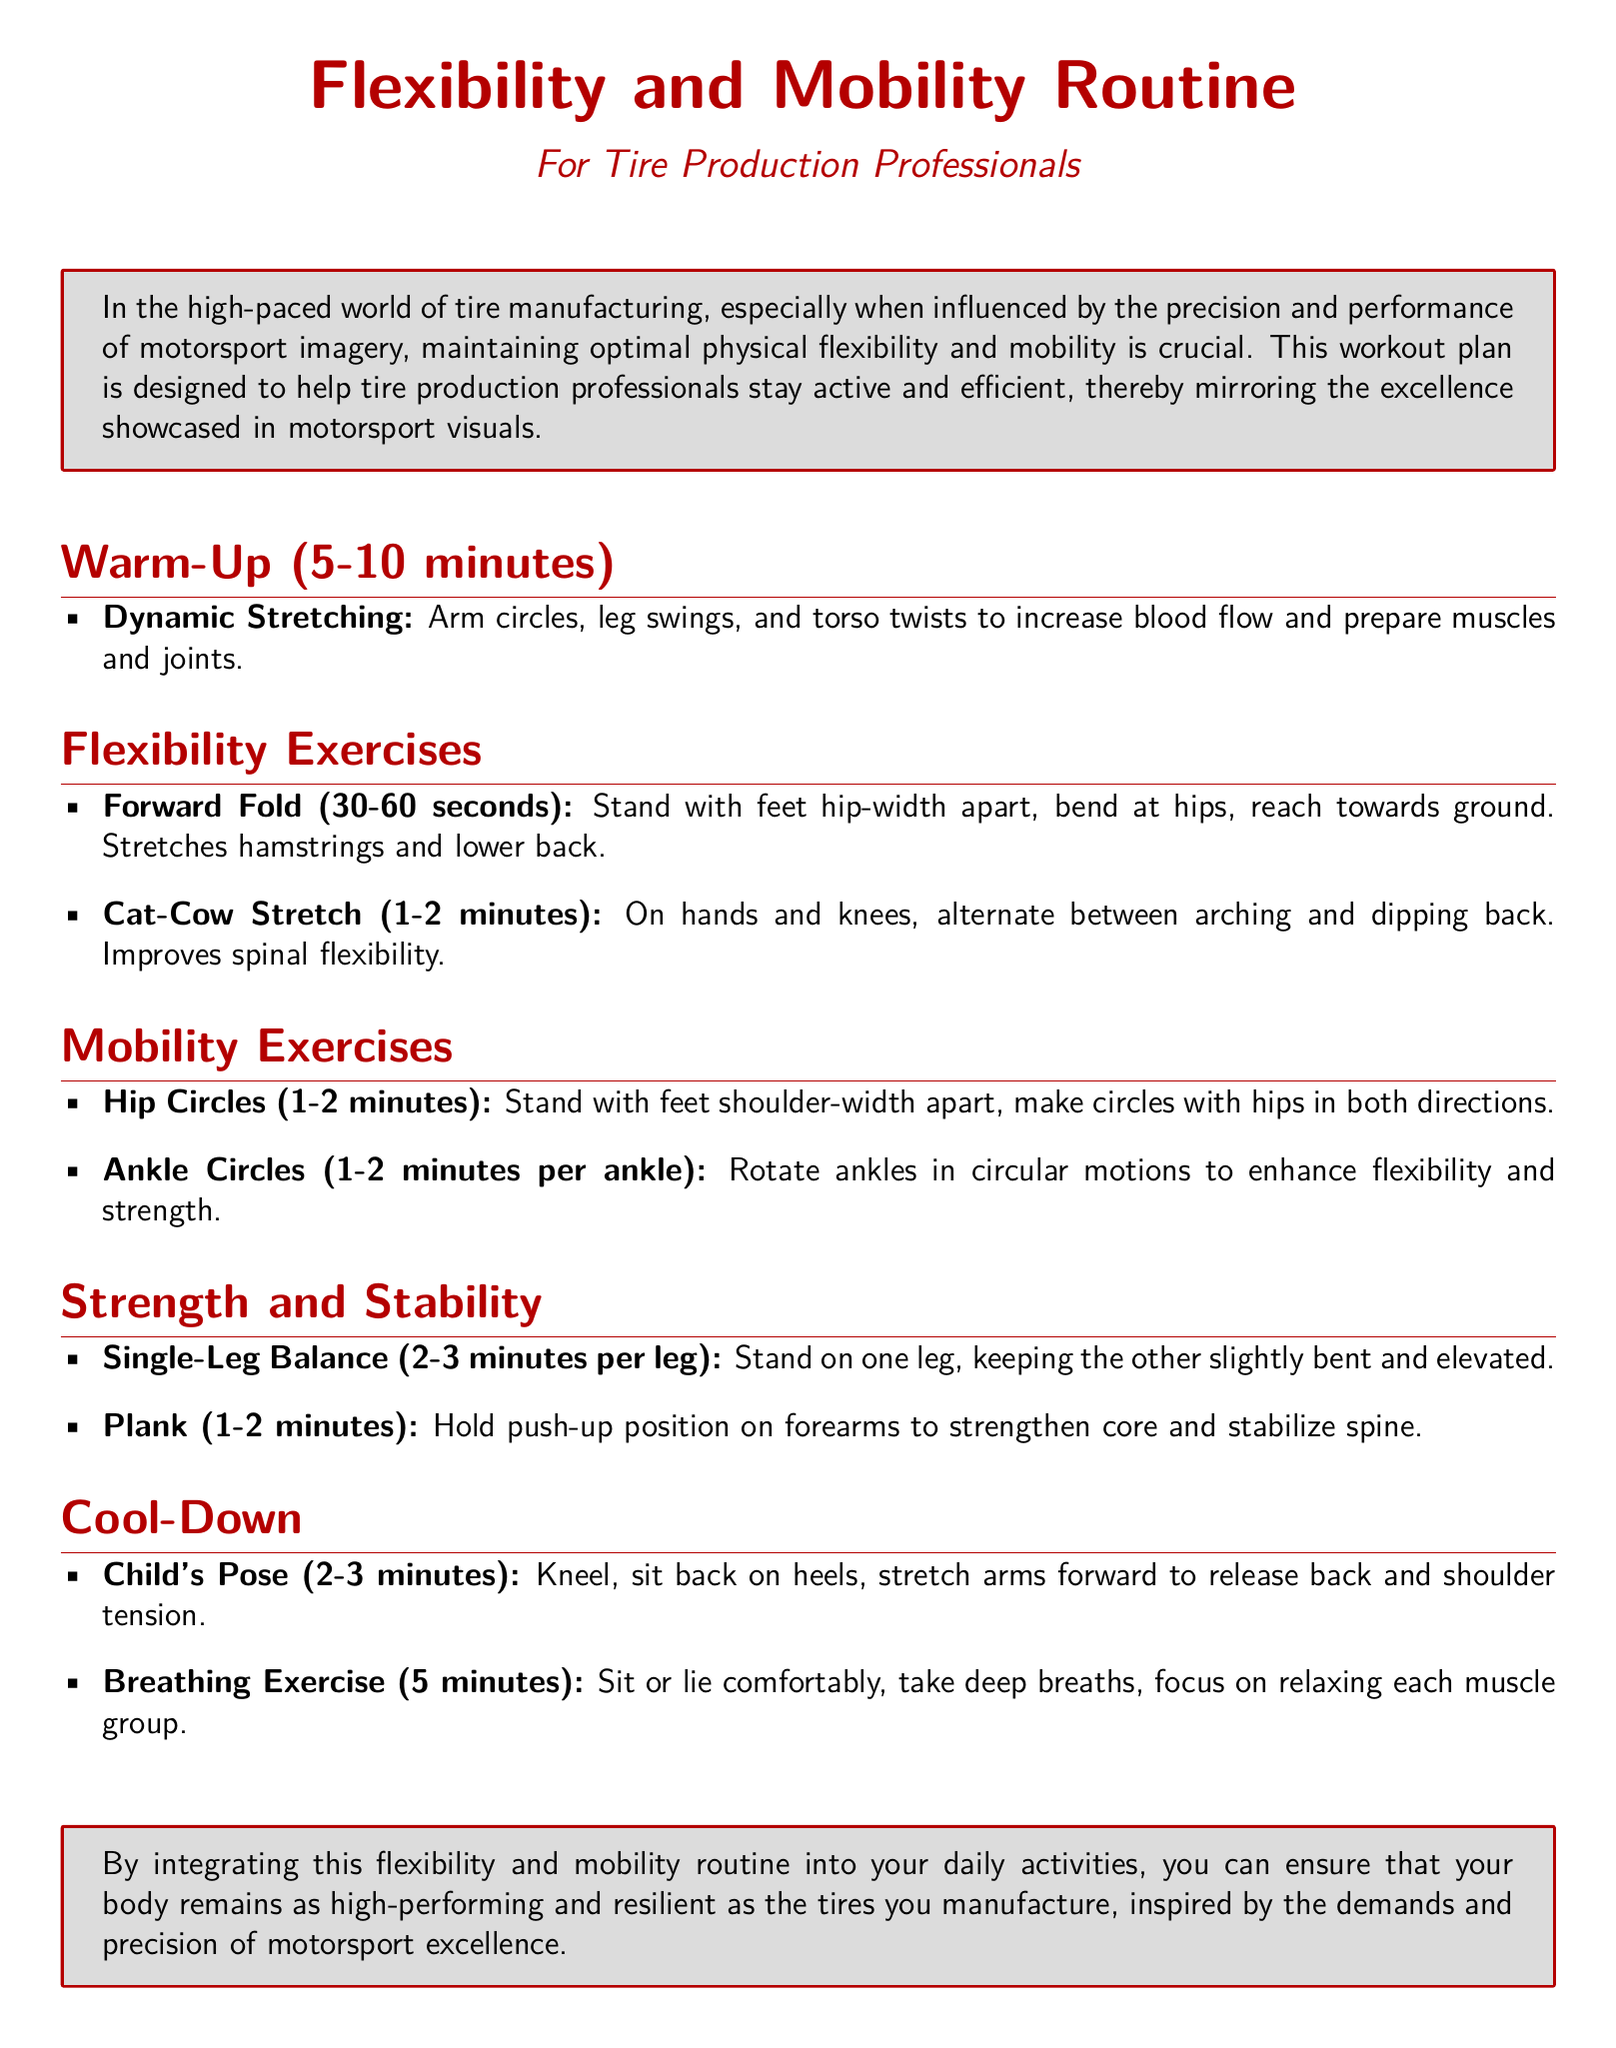what is the purpose of the routine? The purpose is to help tire production professionals stay active and efficient, mirroring motorsport visuals.
Answer: to help stay active and efficient how long should the warm-up last? The warm-up should last between 5 to 10 minutes according to the document.
Answer: 5-10 minutes what exercise helps improve spinal flexibility? The exercise that helps improve spinal flexibility is the Cat-Cow Stretch.
Answer: Cat-Cow Stretch how long is the recommended hold for the Forward Fold? The recommended hold for the Forward Fold is 30 to 60 seconds.
Answer: 30-60 seconds what is the duration for the plank exercise? The plank exercise is recommended for 1 to 2 minutes.
Answer: 1-2 minutes which motion is performed in the Hip Circles exercise? The motion performed is making circles with hips in both directions.
Answer: circles with hips what should you do during the cool-down breathing exercise? During the cool-down breathing exercise, you should take deep breaths and focus on relaxing each muscle group.
Answer: take deep breaths what is emphasized in the document regarding the routine? The routine emphasizes maintaining optimal physical flexibility and mobility.
Answer: optimal physical flexibility and mobility what type of professional is this routine designed for? The routine is designed for tire production professionals.
Answer: tire production professionals 